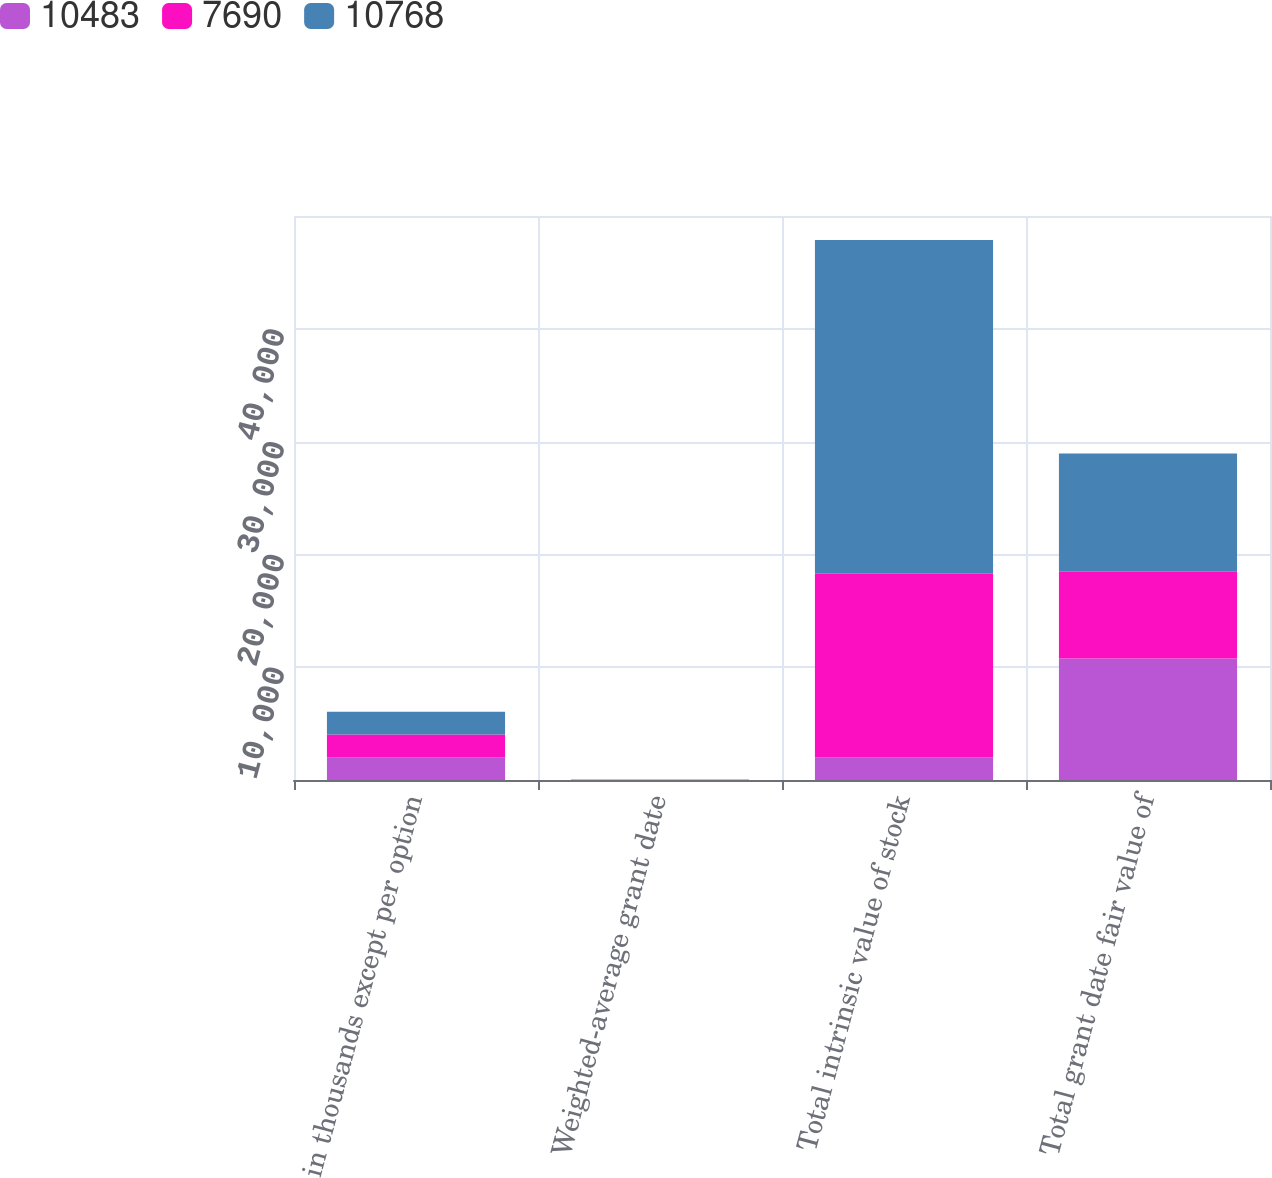Convert chart to OTSL. <chart><loc_0><loc_0><loc_500><loc_500><stacked_bar_chart><ecel><fcel>in thousands except per option<fcel>Weighted-average grant date<fcel>Total intrinsic value of stock<fcel>Total grant date fair value of<nl><fcel>10483<fcel>2017<fcel>19.96<fcel>2017<fcel>10768<nl><fcel>7690<fcel>2016<fcel>13.96<fcel>16273<fcel>7690<nl><fcel>10768<fcel>2015<fcel>14.36<fcel>29574<fcel>10483<nl></chart> 